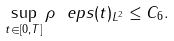Convert formula to latex. <formula><loc_0><loc_0><loc_500><loc_500>\sup _ { t \in [ 0 , T ] } \| \rho _ { \ } e p s ( t ) \| _ { L ^ { 2 } } \leq C _ { 6 } .</formula> 